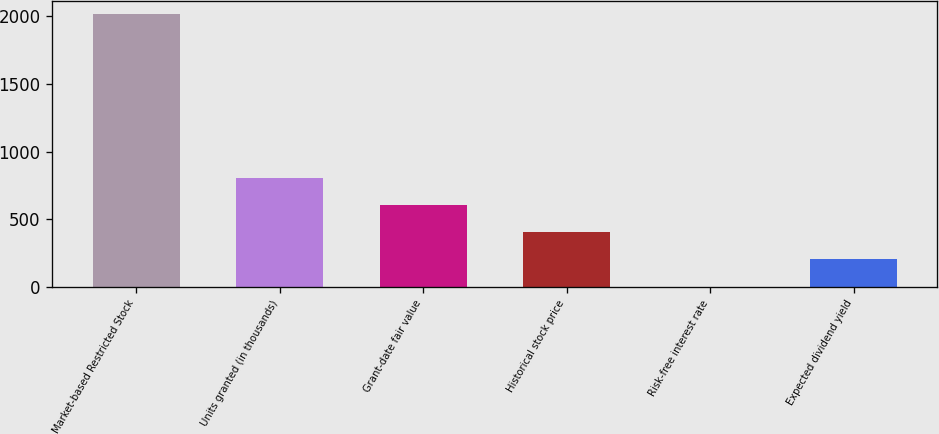<chart> <loc_0><loc_0><loc_500><loc_500><bar_chart><fcel>Market-based Restricted Stock<fcel>Units granted (in thousands)<fcel>Grant-date fair value<fcel>Historical stock price<fcel>Risk-free interest rate<fcel>Expected dividend yield<nl><fcel>2016<fcel>807.06<fcel>605.57<fcel>404.08<fcel>1.1<fcel>202.59<nl></chart> 